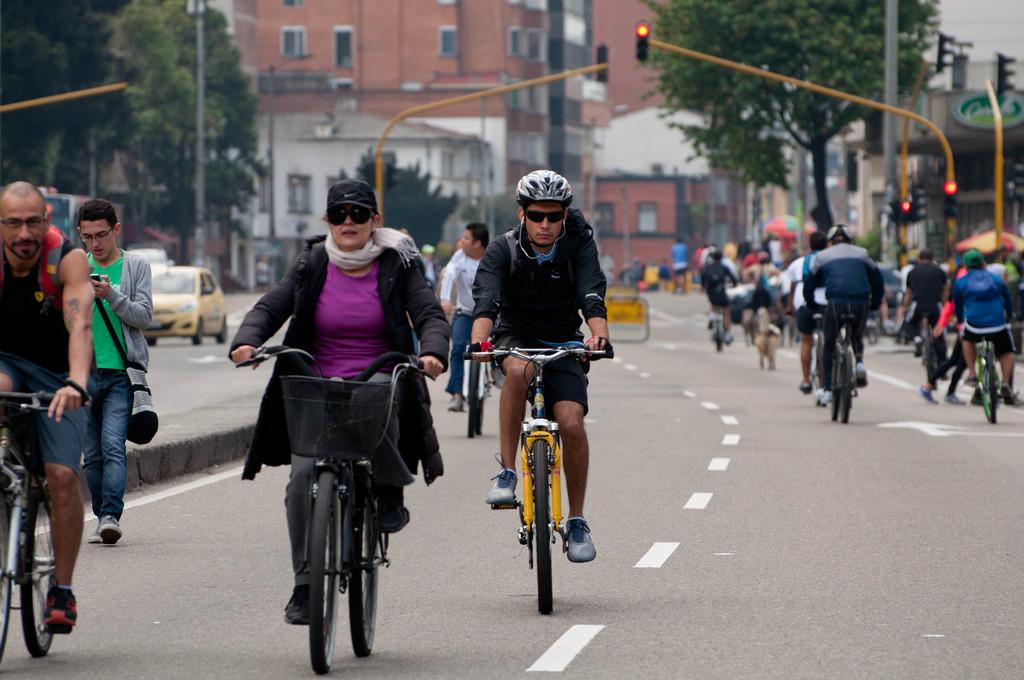How many people are in the image? There are multiple people in the image. What are the people doing in the image? Most of the people are on cycles. Where are the people located in the image? Some people are on a path. What can be seen in the background of the image? There are traffic signals, buildings, and trees in the background. What type of nerve is visible in the image? There is no nerve visible in the image; it features people on cycles and a background with traffic signals, buildings, and trees. 